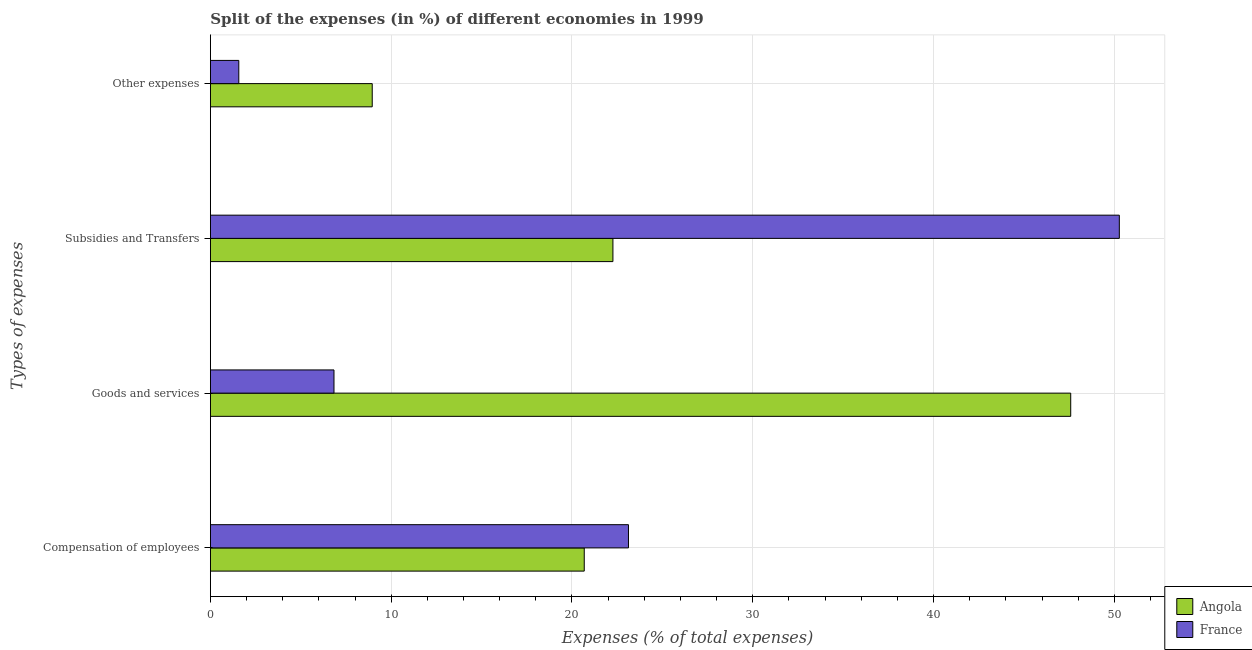How many groups of bars are there?
Provide a succinct answer. 4. Are the number of bars per tick equal to the number of legend labels?
Offer a very short reply. Yes. Are the number of bars on each tick of the Y-axis equal?
Offer a terse response. Yes. How many bars are there on the 3rd tick from the bottom?
Your response must be concise. 2. What is the label of the 2nd group of bars from the top?
Your answer should be compact. Subsidies and Transfers. What is the percentage of amount spent on compensation of employees in France?
Make the answer very short. 23.13. Across all countries, what is the maximum percentage of amount spent on compensation of employees?
Offer a terse response. 23.13. Across all countries, what is the minimum percentage of amount spent on goods and services?
Make the answer very short. 6.84. In which country was the percentage of amount spent on other expenses maximum?
Offer a very short reply. Angola. In which country was the percentage of amount spent on goods and services minimum?
Ensure brevity in your answer.  France. What is the total percentage of amount spent on compensation of employees in the graph?
Your response must be concise. 43.8. What is the difference between the percentage of amount spent on goods and services in France and that in Angola?
Your response must be concise. -40.75. What is the difference between the percentage of amount spent on goods and services in France and the percentage of amount spent on subsidies in Angola?
Your answer should be very brief. -15.43. What is the average percentage of amount spent on goods and services per country?
Your answer should be very brief. 27.21. What is the difference between the percentage of amount spent on subsidies and percentage of amount spent on compensation of employees in France?
Your answer should be compact. 27.15. In how many countries, is the percentage of amount spent on subsidies greater than 28 %?
Offer a very short reply. 1. What is the ratio of the percentage of amount spent on compensation of employees in Angola to that in France?
Your response must be concise. 0.89. Is the percentage of amount spent on other expenses in France less than that in Angola?
Offer a terse response. Yes. What is the difference between the highest and the second highest percentage of amount spent on subsidies?
Your response must be concise. 28.01. What is the difference between the highest and the lowest percentage of amount spent on goods and services?
Provide a succinct answer. 40.75. In how many countries, is the percentage of amount spent on subsidies greater than the average percentage of amount spent on subsidies taken over all countries?
Keep it short and to the point. 1. Is the sum of the percentage of amount spent on subsidies in France and Angola greater than the maximum percentage of amount spent on other expenses across all countries?
Your answer should be very brief. Yes. What does the 2nd bar from the top in Compensation of employees represents?
Your answer should be compact. Angola. What does the 2nd bar from the bottom in Compensation of employees represents?
Provide a short and direct response. France. Are all the bars in the graph horizontal?
Your answer should be very brief. Yes. Are the values on the major ticks of X-axis written in scientific E-notation?
Give a very brief answer. No. How many legend labels are there?
Make the answer very short. 2. What is the title of the graph?
Offer a terse response. Split of the expenses (in %) of different economies in 1999. Does "Togo" appear as one of the legend labels in the graph?
Ensure brevity in your answer.  No. What is the label or title of the X-axis?
Make the answer very short. Expenses (% of total expenses). What is the label or title of the Y-axis?
Your response must be concise. Types of expenses. What is the Expenses (% of total expenses) of Angola in Compensation of employees?
Your response must be concise. 20.68. What is the Expenses (% of total expenses) of France in Compensation of employees?
Your answer should be very brief. 23.13. What is the Expenses (% of total expenses) of Angola in Goods and services?
Keep it short and to the point. 47.59. What is the Expenses (% of total expenses) in France in Goods and services?
Your answer should be very brief. 6.84. What is the Expenses (% of total expenses) of Angola in Subsidies and Transfers?
Offer a very short reply. 22.27. What is the Expenses (% of total expenses) in France in Subsidies and Transfers?
Make the answer very short. 50.28. What is the Expenses (% of total expenses) in Angola in Other expenses?
Provide a short and direct response. 8.95. What is the Expenses (% of total expenses) of France in Other expenses?
Provide a short and direct response. 1.57. Across all Types of expenses, what is the maximum Expenses (% of total expenses) in Angola?
Your response must be concise. 47.59. Across all Types of expenses, what is the maximum Expenses (% of total expenses) of France?
Provide a short and direct response. 50.28. Across all Types of expenses, what is the minimum Expenses (% of total expenses) in Angola?
Provide a short and direct response. 8.95. Across all Types of expenses, what is the minimum Expenses (% of total expenses) of France?
Give a very brief answer. 1.57. What is the total Expenses (% of total expenses) of Angola in the graph?
Your answer should be very brief. 99.48. What is the total Expenses (% of total expenses) of France in the graph?
Your answer should be compact. 81.81. What is the difference between the Expenses (% of total expenses) in Angola in Compensation of employees and that in Goods and services?
Make the answer very short. -26.91. What is the difference between the Expenses (% of total expenses) in France in Compensation of employees and that in Goods and services?
Offer a terse response. 16.29. What is the difference between the Expenses (% of total expenses) of Angola in Compensation of employees and that in Subsidies and Transfers?
Offer a very short reply. -1.59. What is the difference between the Expenses (% of total expenses) in France in Compensation of employees and that in Subsidies and Transfers?
Keep it short and to the point. -27.15. What is the difference between the Expenses (% of total expenses) of Angola in Compensation of employees and that in Other expenses?
Offer a very short reply. 11.73. What is the difference between the Expenses (% of total expenses) in France in Compensation of employees and that in Other expenses?
Offer a very short reply. 21.55. What is the difference between the Expenses (% of total expenses) of Angola in Goods and services and that in Subsidies and Transfers?
Make the answer very short. 25.32. What is the difference between the Expenses (% of total expenses) of France in Goods and services and that in Subsidies and Transfers?
Offer a terse response. -43.44. What is the difference between the Expenses (% of total expenses) of Angola in Goods and services and that in Other expenses?
Offer a very short reply. 38.64. What is the difference between the Expenses (% of total expenses) in France in Goods and services and that in Other expenses?
Ensure brevity in your answer.  5.27. What is the difference between the Expenses (% of total expenses) of Angola in Subsidies and Transfers and that in Other expenses?
Your answer should be very brief. 13.31. What is the difference between the Expenses (% of total expenses) of France in Subsidies and Transfers and that in Other expenses?
Provide a short and direct response. 48.7. What is the difference between the Expenses (% of total expenses) of Angola in Compensation of employees and the Expenses (% of total expenses) of France in Goods and services?
Provide a succinct answer. 13.84. What is the difference between the Expenses (% of total expenses) of Angola in Compensation of employees and the Expenses (% of total expenses) of France in Subsidies and Transfers?
Give a very brief answer. -29.6. What is the difference between the Expenses (% of total expenses) in Angola in Compensation of employees and the Expenses (% of total expenses) in France in Other expenses?
Your answer should be very brief. 19.11. What is the difference between the Expenses (% of total expenses) of Angola in Goods and services and the Expenses (% of total expenses) of France in Subsidies and Transfers?
Your response must be concise. -2.69. What is the difference between the Expenses (% of total expenses) in Angola in Goods and services and the Expenses (% of total expenses) in France in Other expenses?
Your response must be concise. 46.02. What is the difference between the Expenses (% of total expenses) of Angola in Subsidies and Transfers and the Expenses (% of total expenses) of France in Other expenses?
Your answer should be compact. 20.69. What is the average Expenses (% of total expenses) in Angola per Types of expenses?
Your answer should be very brief. 24.87. What is the average Expenses (% of total expenses) in France per Types of expenses?
Your answer should be compact. 20.45. What is the difference between the Expenses (% of total expenses) in Angola and Expenses (% of total expenses) in France in Compensation of employees?
Keep it short and to the point. -2.45. What is the difference between the Expenses (% of total expenses) in Angola and Expenses (% of total expenses) in France in Goods and services?
Provide a succinct answer. 40.75. What is the difference between the Expenses (% of total expenses) of Angola and Expenses (% of total expenses) of France in Subsidies and Transfers?
Keep it short and to the point. -28.01. What is the difference between the Expenses (% of total expenses) of Angola and Expenses (% of total expenses) of France in Other expenses?
Offer a terse response. 7.38. What is the ratio of the Expenses (% of total expenses) of Angola in Compensation of employees to that in Goods and services?
Keep it short and to the point. 0.43. What is the ratio of the Expenses (% of total expenses) in France in Compensation of employees to that in Goods and services?
Make the answer very short. 3.38. What is the ratio of the Expenses (% of total expenses) in Angola in Compensation of employees to that in Subsidies and Transfers?
Give a very brief answer. 0.93. What is the ratio of the Expenses (% of total expenses) of France in Compensation of employees to that in Subsidies and Transfers?
Offer a very short reply. 0.46. What is the ratio of the Expenses (% of total expenses) in Angola in Compensation of employees to that in Other expenses?
Ensure brevity in your answer.  2.31. What is the ratio of the Expenses (% of total expenses) in France in Compensation of employees to that in Other expenses?
Provide a succinct answer. 14.72. What is the ratio of the Expenses (% of total expenses) in Angola in Goods and services to that in Subsidies and Transfers?
Provide a succinct answer. 2.14. What is the ratio of the Expenses (% of total expenses) in France in Goods and services to that in Subsidies and Transfers?
Offer a terse response. 0.14. What is the ratio of the Expenses (% of total expenses) in Angola in Goods and services to that in Other expenses?
Give a very brief answer. 5.32. What is the ratio of the Expenses (% of total expenses) of France in Goods and services to that in Other expenses?
Your answer should be compact. 4.35. What is the ratio of the Expenses (% of total expenses) in Angola in Subsidies and Transfers to that in Other expenses?
Provide a succinct answer. 2.49. What is the ratio of the Expenses (% of total expenses) in France in Subsidies and Transfers to that in Other expenses?
Provide a succinct answer. 32. What is the difference between the highest and the second highest Expenses (% of total expenses) in Angola?
Ensure brevity in your answer.  25.32. What is the difference between the highest and the second highest Expenses (% of total expenses) of France?
Your response must be concise. 27.15. What is the difference between the highest and the lowest Expenses (% of total expenses) of Angola?
Offer a terse response. 38.64. What is the difference between the highest and the lowest Expenses (% of total expenses) of France?
Ensure brevity in your answer.  48.7. 